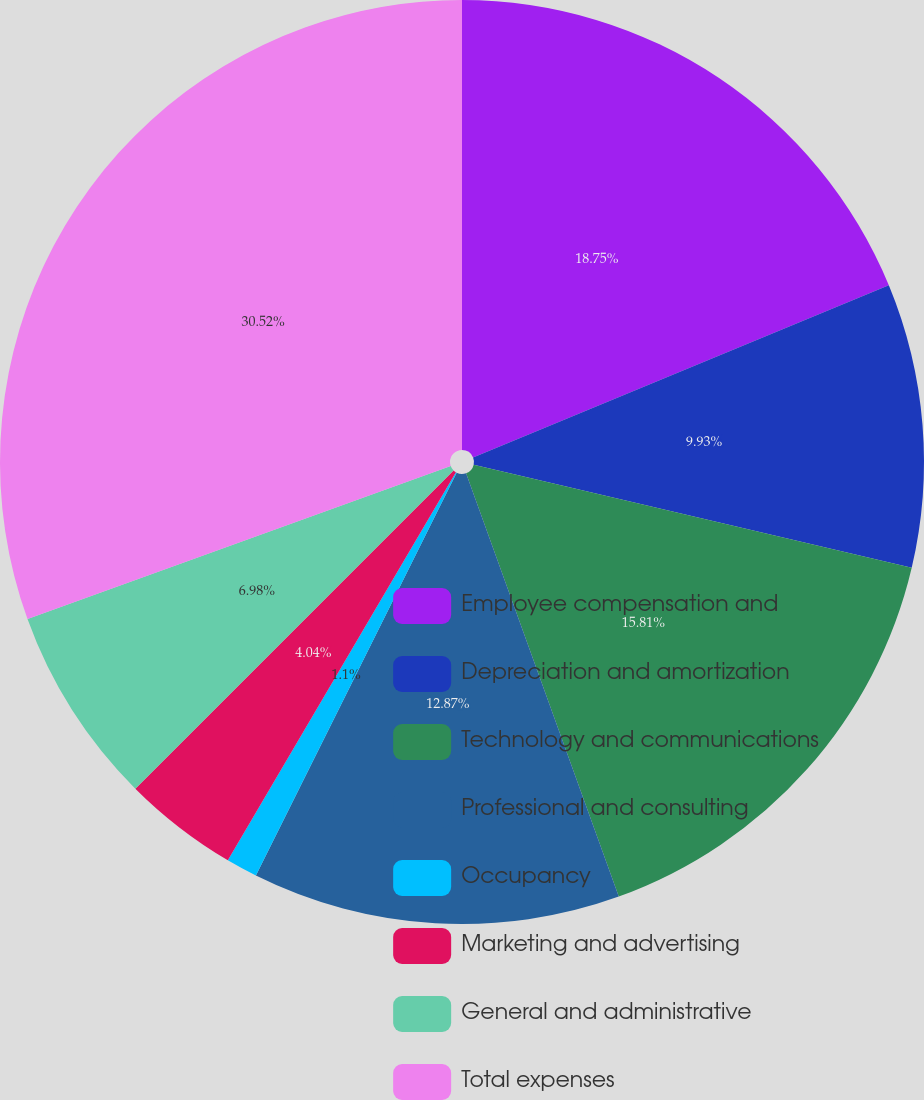Convert chart to OTSL. <chart><loc_0><loc_0><loc_500><loc_500><pie_chart><fcel>Employee compensation and<fcel>Depreciation and amortization<fcel>Technology and communications<fcel>Professional and consulting<fcel>Occupancy<fcel>Marketing and advertising<fcel>General and administrative<fcel>Total expenses<nl><fcel>18.75%<fcel>9.93%<fcel>15.81%<fcel>12.87%<fcel>1.1%<fcel>4.04%<fcel>6.98%<fcel>30.52%<nl></chart> 